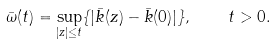<formula> <loc_0><loc_0><loc_500><loc_500>\bar { \omega } ( t ) = \sup _ { | z | \leq t } \{ | \bar { k } ( z ) - \bar { k } ( 0 ) | \} , \quad t > 0 .</formula> 